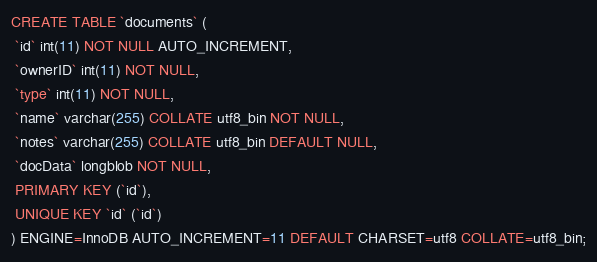<code> <loc_0><loc_0><loc_500><loc_500><_SQL_>CREATE TABLE `documents` (
 `id` int(11) NOT NULL AUTO_INCREMENT,
 `ownerID` int(11) NOT NULL,
 `type` int(11) NOT NULL,
 `name` varchar(255) COLLATE utf8_bin NOT NULL,
 `notes` varchar(255) COLLATE utf8_bin DEFAULT NULL,
 `docData` longblob NOT NULL,
 PRIMARY KEY (`id`),
 UNIQUE KEY `id` (`id`)
) ENGINE=InnoDB AUTO_INCREMENT=11 DEFAULT CHARSET=utf8 COLLATE=utf8_bin;
</code> 